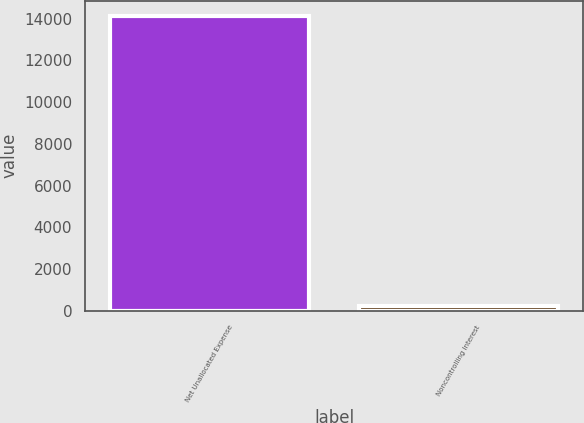Convert chart to OTSL. <chart><loc_0><loc_0><loc_500><loc_500><bar_chart><fcel>Net Unallocated Expense<fcel>Noncontrolling Interest<nl><fcel>14144<fcel>209<nl></chart> 